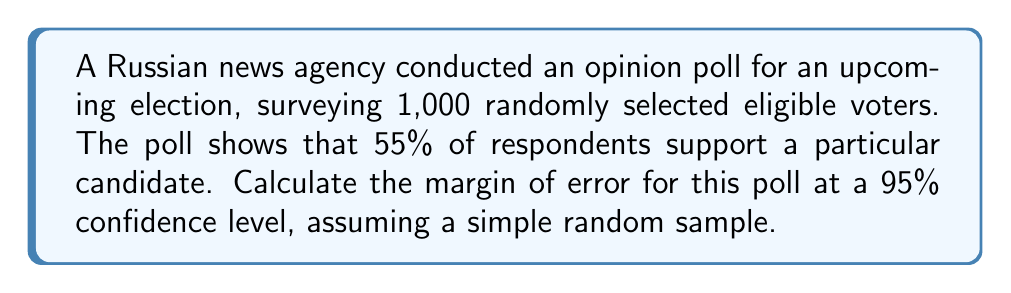Show me your answer to this math problem. To calculate the margin of error for this opinion poll, we'll use the formula for the margin of error in a proportion:

$$ ME = z \sqrt{\frac{p(1-p)}{n}} $$

Where:
- $ME$ is the margin of error
- $z$ is the z-score for the desired confidence level
- $p$ is the sample proportion
- $n$ is the sample size

Step 1: Identify the known values
- Confidence level: 95% (z-score = 1.96)
- Sample proportion (p): 55% = 0.55
- Sample size (n): 1,000

Step 2: Plug the values into the formula
$$ ME = 1.96 \sqrt{\frac{0.55(1-0.55)}{1000}} $$

Step 3: Simplify the expression under the square root
$$ ME = 1.96 \sqrt{\frac{0.55(0.45)}{1000}} = 1.96 \sqrt{\frac{0.2475}{1000}} $$

Step 4: Calculate the result
$$ ME = 1.96 \sqrt{0.0002475} \approx 1.96 \times 0.01573 \approx 0.03083 $$

Step 5: Convert to percentage
$$ ME \approx 0.03083 \times 100\% \approx 3.08\% $$

Therefore, the margin of error for this poll is approximately 3.08%.
Answer: 3.08% 